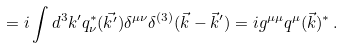<formula> <loc_0><loc_0><loc_500><loc_500>= i \int d ^ { 3 } k ^ { \prime } q _ { \nu } ^ { * } ( \vec { k ^ { \prime } } ) \delta ^ { \mu \nu } \delta ^ { ( 3 ) } ( \vec { k } - \vec { k } ^ { \prime } ) = i g ^ { \mu \mu } q ^ { \mu } ( \vec { k } ) ^ { * } \, .</formula> 